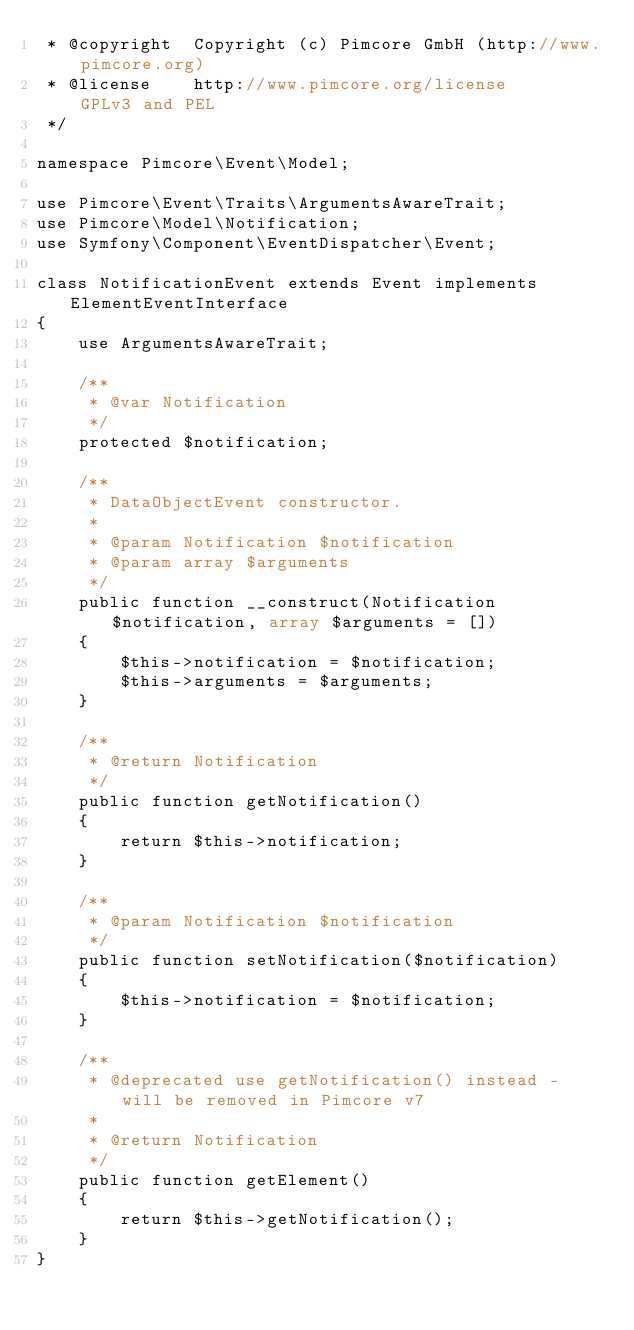<code> <loc_0><loc_0><loc_500><loc_500><_PHP_> * @copyright  Copyright (c) Pimcore GmbH (http://www.pimcore.org)
 * @license    http://www.pimcore.org/license     GPLv3 and PEL
 */

namespace Pimcore\Event\Model;

use Pimcore\Event\Traits\ArgumentsAwareTrait;
use Pimcore\Model\Notification;
use Symfony\Component\EventDispatcher\Event;

class NotificationEvent extends Event implements ElementEventInterface
{
    use ArgumentsAwareTrait;

    /**
     * @var Notification
     */
    protected $notification;

    /**
     * DataObjectEvent constructor.
     *
     * @param Notification $notification
     * @param array $arguments
     */
    public function __construct(Notification $notification, array $arguments = [])
    {
        $this->notification = $notification;
        $this->arguments = $arguments;
    }

    /**
     * @return Notification
     */
    public function getNotification()
    {
        return $this->notification;
    }

    /**
     * @param Notification $notification
     */
    public function setNotification($notification)
    {
        $this->notification = $notification;
    }

    /**
     * @deprecated use getNotification() instead - will be removed in Pimcore v7
     *
     * @return Notification
     */
    public function getElement()
    {
        return $this->getNotification();
    }
}
</code> 